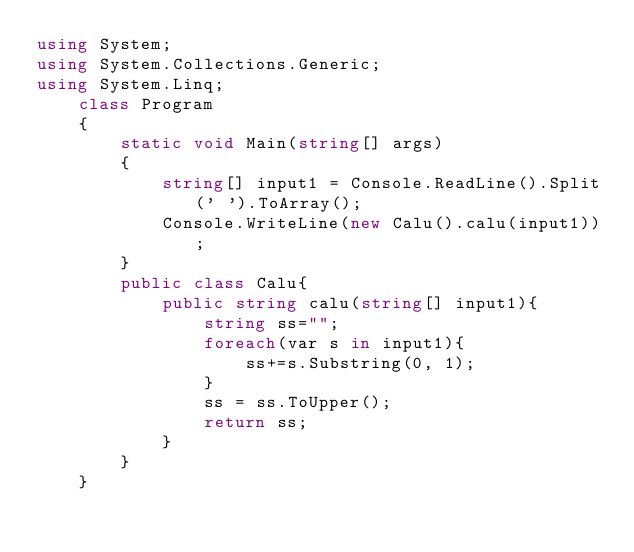<code> <loc_0><loc_0><loc_500><loc_500><_C#_>using System;
using System.Collections.Generic;
using System.Linq;
    class Program
    {
        static void Main(string[] args)
        {
            string[] input1 = Console.ReadLine().Split(' ').ToArray();
            Console.WriteLine(new Calu().calu(input1));
        }
        public class Calu{
            public string calu(string[] input1){
                string ss="";
                foreach(var s in input1){
                    ss+=s.Substring(0, 1);
                }
                ss = ss.ToUpper();
                return ss;
            }
        }
    }</code> 